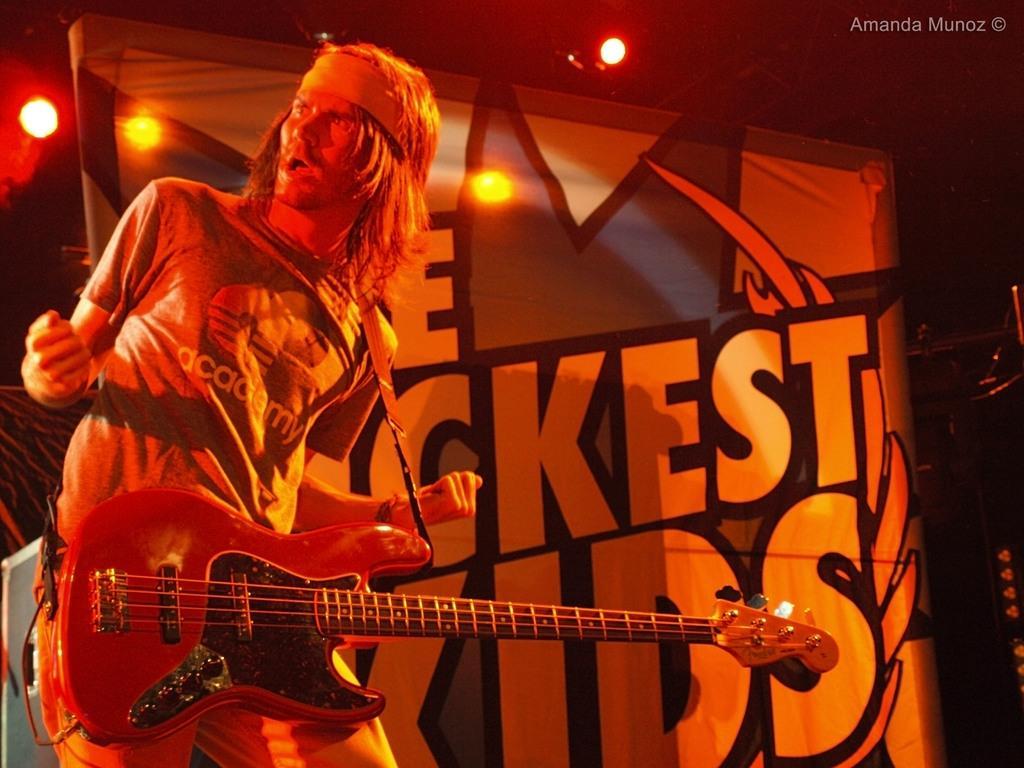Can you describe this image briefly? This image is clicked in a concert. There is a man standing on the left side he is playing guitar. He is wearing shirt and pant. There are lights on the top middle of the image. There is a banner back of him. 